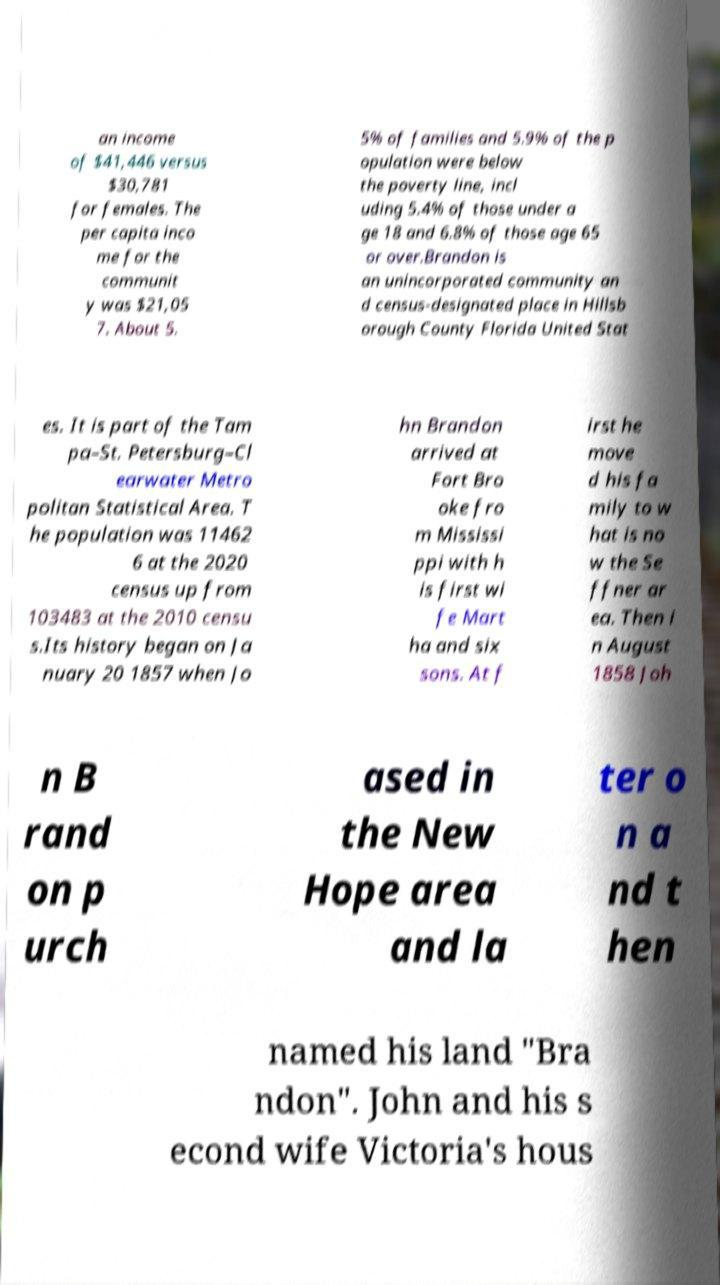Can you read and provide the text displayed in the image?This photo seems to have some interesting text. Can you extract and type it out for me? an income of $41,446 versus $30,781 for females. The per capita inco me for the communit y was $21,05 7. About 5. 5% of families and 5.9% of the p opulation were below the poverty line, incl uding 5.4% of those under a ge 18 and 6.8% of those age 65 or over.Brandon is an unincorporated community an d census-designated place in Hillsb orough County Florida United Stat es. It is part of the Tam pa–St. Petersburg–Cl earwater Metro politan Statistical Area. T he population was 11462 6 at the 2020 census up from 103483 at the 2010 censu s.Its history began on Ja nuary 20 1857 when Jo hn Brandon arrived at Fort Bro oke fro m Mississi ppi with h is first wi fe Mart ha and six sons. At f irst he move d his fa mily to w hat is no w the Se ffner ar ea. Then i n August 1858 Joh n B rand on p urch ased in the New Hope area and la ter o n a nd t hen named his land "Bra ndon". John and his s econd wife Victoria's hous 